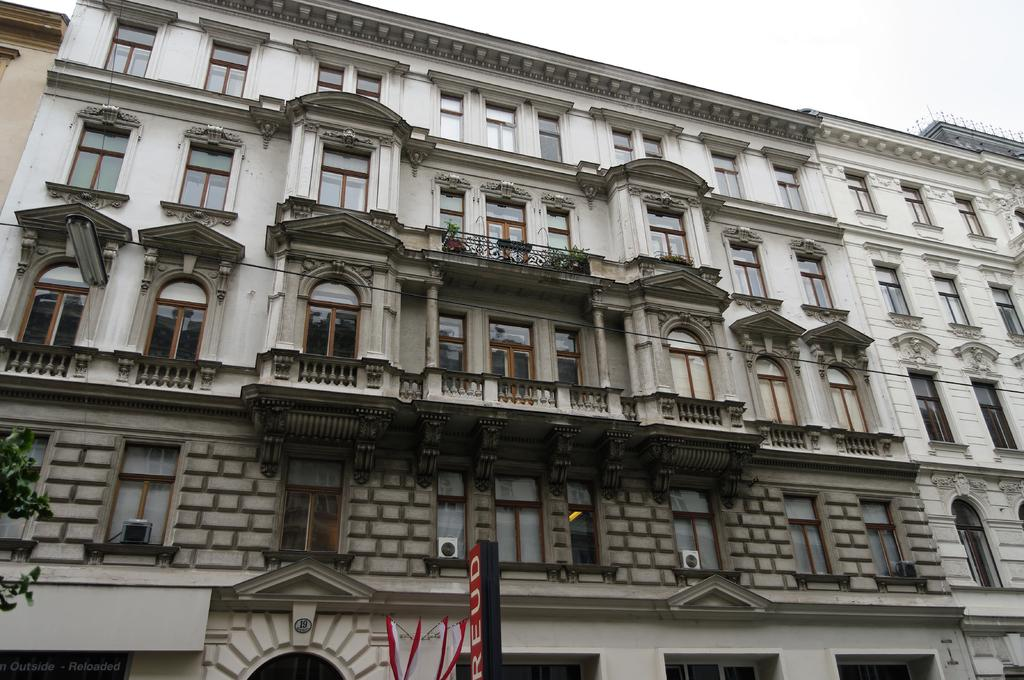What type of structures can be seen in the image? There are buildings in the image. What appliances are visible on the buildings? Air conditioners are visible in the image. What type of greenery is present in the image? House plants and a tree are present in the image. What is the purpose of the board in the image? The purpose of the board in the image is not specified, but it might be used for displaying information or as a sign. Can you describe any other objects in the image? There are other objects in the image, but their specific details are not mentioned in the provided facts. What can be seen in the background of the image? The sky is visible in the background of the image. How many feet are visible in the image? There are no feet visible in the image. What type of impulse can be seen affecting the air conditioners in the image? There is no impulse affecting the air conditioners in the image; they are stationary. Is there a chain connecting the buildings in the image? There is no chain connecting the buildings in the image. 